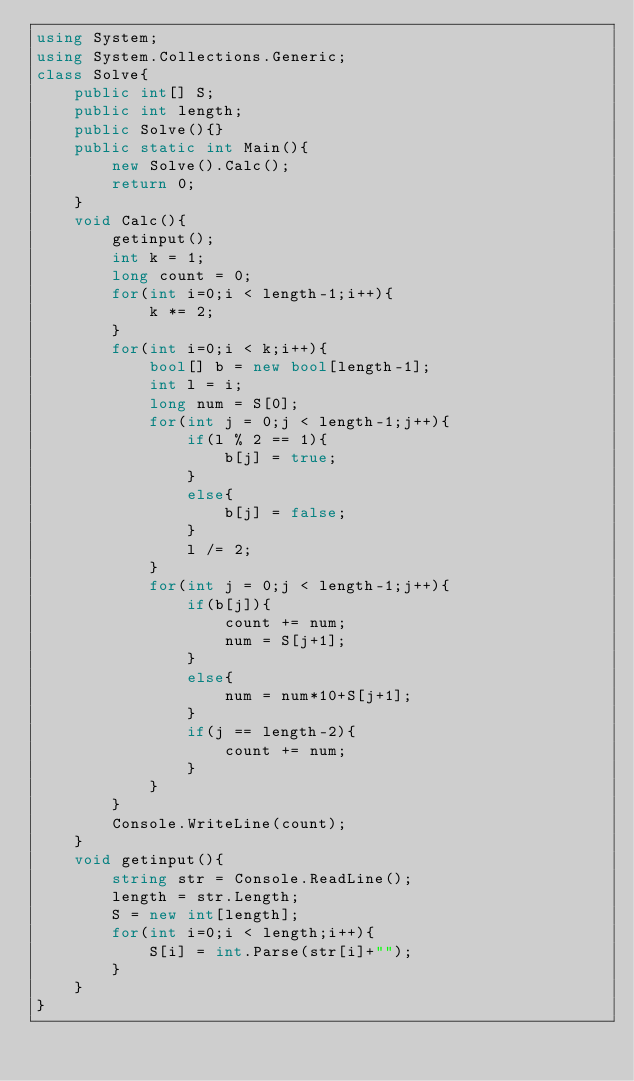Convert code to text. <code><loc_0><loc_0><loc_500><loc_500><_C#_>using System;
using System.Collections.Generic;
class Solve{
    public int[] S;
    public int length;
    public Solve(){}
    public static int Main(){
        new Solve().Calc();
        return 0;
    }
    void Calc(){
        getinput();
        int k = 1;
        long count = 0;
        for(int i=0;i < length-1;i++){
            k *= 2;
        }
        for(int i=0;i < k;i++){
            bool[] b = new bool[length-1];
            int l = i;
            long num = S[0];
            for(int j = 0;j < length-1;j++){
                if(l % 2 == 1){
                    b[j] = true;
                }
                else{
                    b[j] = false;
                }
                l /= 2;
            }
            for(int j = 0;j < length-1;j++){
                if(b[j]){
                    count += num;
                    num = S[j+1];
                }
                else{
                    num = num*10+S[j+1];
                }
                if(j == length-2){
                    count += num;
                }
            }
        }
        Console.WriteLine(count);
    }
    void getinput(){
        string str = Console.ReadLine();
        length = str.Length;
        S = new int[length];
        for(int i=0;i < length;i++){
            S[i] = int.Parse(str[i]+"");
        }
    }    
}</code> 